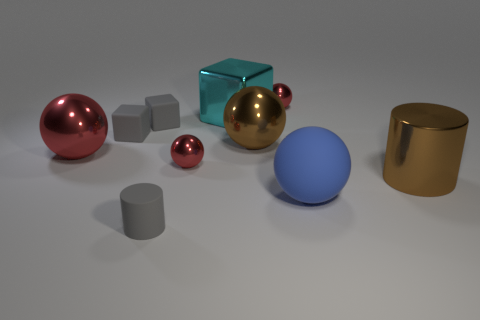How many gray cubes must be subtracted to get 1 gray cubes? 1 Subtract all red blocks. How many red balls are left? 3 Subtract all large brown spheres. How many spheres are left? 4 Subtract all yellow spheres. Subtract all green cubes. How many spheres are left? 5 Subtract all cylinders. How many objects are left? 8 Subtract 0 yellow cylinders. How many objects are left? 10 Subtract all small green cubes. Subtract all red shiny objects. How many objects are left? 7 Add 2 small gray rubber objects. How many small gray rubber objects are left? 5 Add 2 large metal cubes. How many large metal cubes exist? 3 